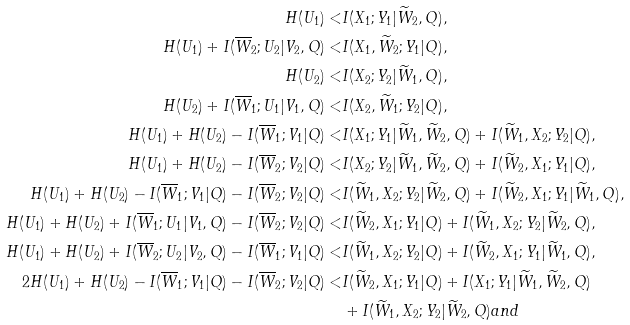Convert formula to latex. <formula><loc_0><loc_0><loc_500><loc_500>H ( U _ { 1 } ) < & I ( X _ { 1 } ; Y _ { 1 } | \widetilde { W } _ { 2 } , Q ) , \\ H ( U _ { 1 } ) + I ( \overline { W } _ { 2 } ; U _ { 2 } | V _ { 2 } , Q ) < & I ( X _ { 1 } , \widetilde { W } _ { 2 } ; Y _ { 1 } | Q ) , \\ H ( U _ { 2 } ) < & I ( X _ { 2 } ; Y _ { 2 } | \widetilde { W } _ { 1 } , Q ) , \\ H ( U _ { 2 } ) + I ( \overline { W } _ { 1 } ; U _ { 1 } | V _ { 1 } , Q ) < & I ( X _ { 2 } , \widetilde { W } _ { 1 } ; Y _ { 2 } | Q ) , \\ H ( U _ { 1 } ) + H ( U _ { 2 } ) - I ( \overline { W } _ { 1 } ; V _ { 1 } | Q ) < & I ( X _ { 1 } ; Y _ { 1 } | \widetilde { W } _ { 1 } , \widetilde { W } _ { 2 } , Q ) + I ( \widetilde { W } _ { 1 } , X _ { 2 } ; Y _ { 2 } | Q ) , \\ H ( U _ { 1 } ) + H ( U _ { 2 } ) - I ( \overline { W } _ { 2 } ; V _ { 2 } | Q ) < & I ( X _ { 2 } ; Y _ { 2 } | \widetilde { W } _ { 1 } , \widetilde { W } _ { 2 } , Q ) + I ( \widetilde { W } _ { 2 } , X _ { 1 } ; Y _ { 1 } | Q ) , \\ H ( U _ { 1 } ) + H ( U _ { 2 } ) - I ( \overline { W } _ { 1 } ; V _ { 1 } | Q ) - I ( \overline { W } _ { 2 } ; V _ { 2 } | Q ) < & I ( \widetilde { W } _ { 1 } , X _ { 2 } ; Y _ { 2 } | \widetilde { W } _ { 2 } , Q ) + I ( \widetilde { W } _ { 2 } , X _ { 1 } ; Y _ { 1 } | \widetilde { W } _ { 1 } , Q ) , \\ H ( U _ { 1 } ) + H ( U _ { 2 } ) + I ( \overline { W } _ { 1 } ; U _ { 1 } | V _ { 1 } , Q ) - I ( \overline { W } _ { 2 } ; V _ { 2 } | Q ) < & I ( \widetilde { W } _ { 2 } , X _ { 1 } ; Y _ { 1 } | Q ) + I ( \widetilde { W } _ { 1 } , X _ { 2 } ; Y _ { 2 } | \widetilde { W } _ { 2 } , Q ) , \\ H ( U _ { 1 } ) + H ( U _ { 2 } ) + I ( \overline { W } _ { 2 } ; U _ { 2 } | V _ { 2 } , Q ) - I ( \overline { W } _ { 1 } ; V _ { 1 } | Q ) < & I ( \widetilde { W } _ { 1 } , X _ { 2 } ; Y _ { 2 } | Q ) + I ( \widetilde { W } _ { 2 } , X _ { 1 } ; Y _ { 1 } | \widetilde { W } _ { 1 } , Q ) , \\ 2 H ( U _ { 1 } ) + H ( U _ { 2 } ) - I ( \overline { W } _ { 1 } ; V _ { 1 } | Q ) - I ( \overline { W } _ { 2 } ; V _ { 2 } | Q ) < & I ( \widetilde { W } _ { 2 } , X _ { 1 } ; Y _ { 1 } | Q ) + I ( X _ { 1 } ; Y _ { 1 } | \widetilde { W } _ { 1 } , \widetilde { W } _ { 2 } , Q ) \\ & + I ( \widetilde { W } _ { 1 } , X _ { 2 } ; Y _ { 2 } | \widetilde { W } _ { 2 } , Q ) a n d</formula> 